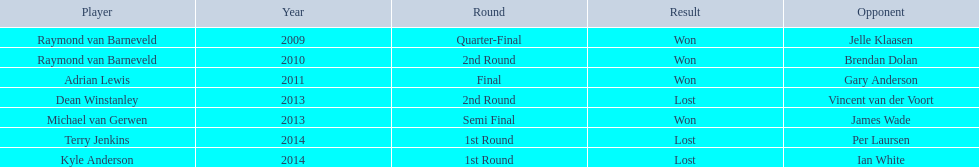Who are the team members? Raymond van Barneveld, Raymond van Barneveld, Adrian Lewis, Dean Winstanley, Michael van Gerwen, Terry Jenkins, Kyle Anderson. When was their playtime? 2009, 2010, 2011, 2013, 2013, 2014, 2014. Additionally, who among them played in 2011? Adrian Lewis. 